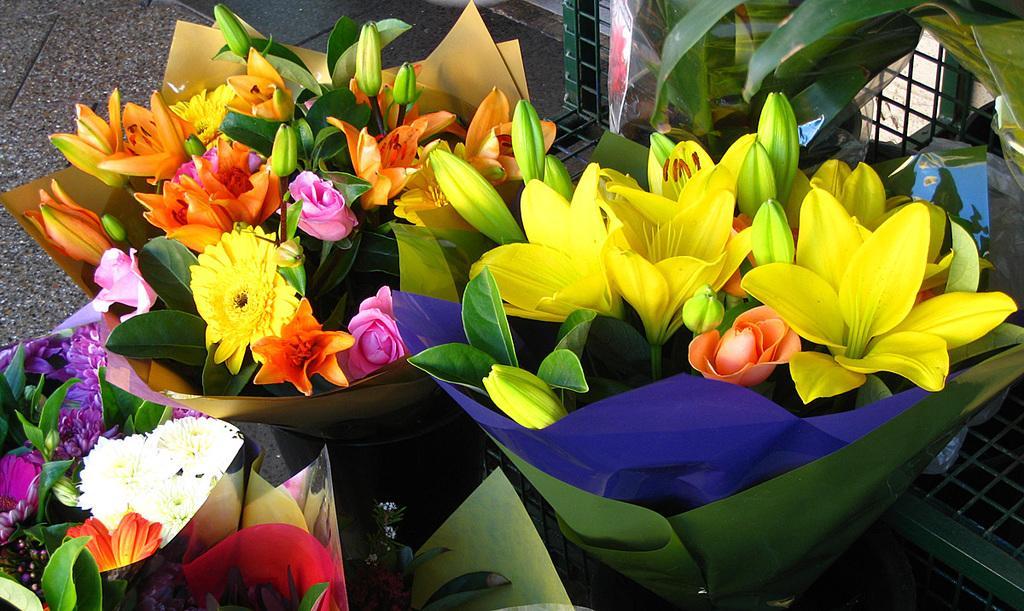In one or two sentences, can you explain what this image depicts? In this image we can see flower bouquets placed on the ground. 